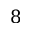Convert formula to latex. <formula><loc_0><loc_0><loc_500><loc_500>8</formula> 